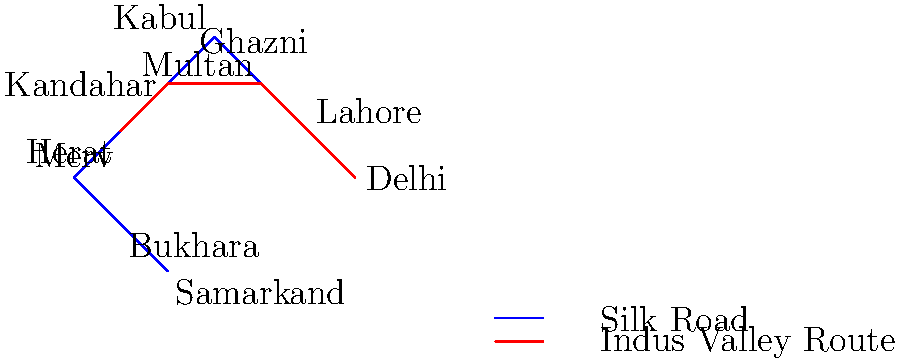Based on the map of trade routes during the Sultanate period, which city served as a crucial junction connecting the Silk Road with the Indus Valley trade route, making it a significant economic center? To answer this question, we need to analyze the trade routes shown on the map:

1. The blue line represents the Silk Road, connecting cities like Samarkand, Bukhara, Merv, Herat, Ghazni, Kabul, Lahore, and Delhi.

2. The red line represents the Indus Valley trade route, connecting Delhi, Lahore, Multan, Kandahar, and Herat.

3. We need to identify a city where these two major trade routes intersect or converge.

4. Looking at the map, we can see that Lahore is positioned at the intersection of both the blue (Silk Road) and red (Indus Valley) routes.

5. Lahore's strategic location allowed it to facilitate trade between the Silk Road and the Indus Valley, making it an important economic hub during the Sultanate period.

6. Other cities like Delhi, Multan, and Herat were also important, but Lahore's unique position as a junction between these two major routes gave it a distinct advantage.

Therefore, Lahore served as the crucial junction connecting the Silk Road with the Indus Valley trade route, making it a significant economic center during the Sultanate period.
Answer: Lahore 